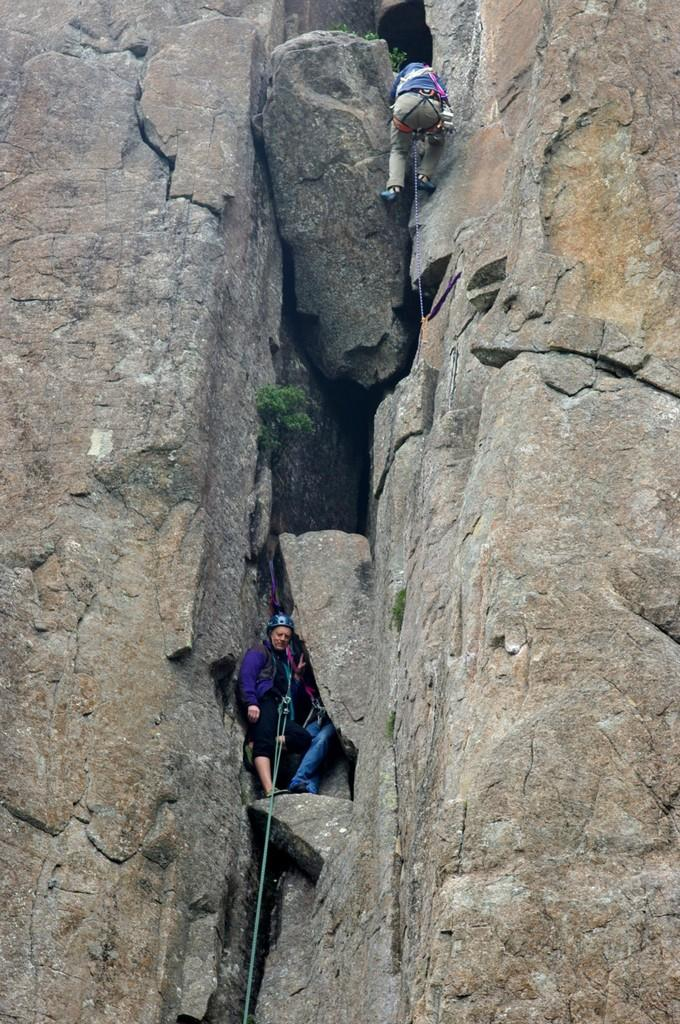How many people are in the image? There are two people in the image. What are the two people doing in the image? The two people are climbing rocks. What type of fire can be seen in the image? There is no fire present in the image. What type of club is being used by one of the climbers in the image? There is no club visible in the image; the two people are only climbing rocks. 